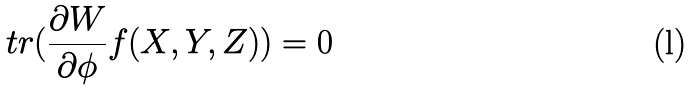Convert formula to latex. <formula><loc_0><loc_0><loc_500><loc_500>\ t r ( \frac { \partial W } { \partial \phi } f ( X , Y , Z ) ) = 0</formula> 